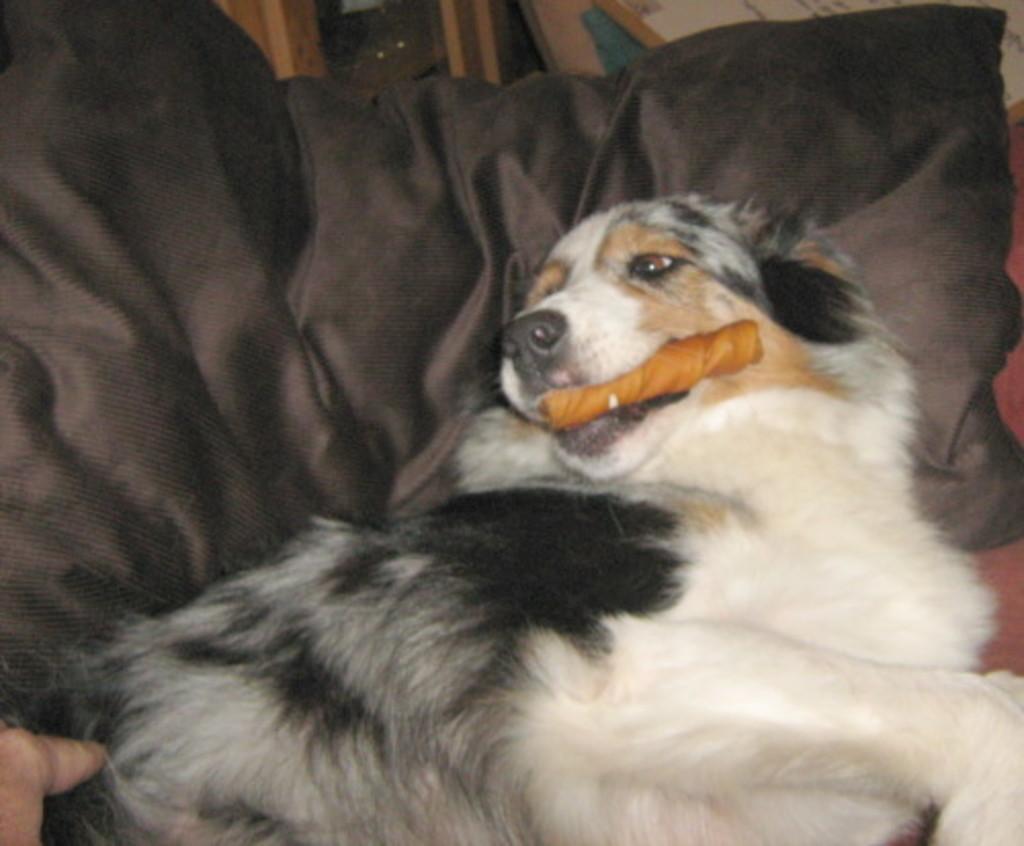In one or two sentences, can you explain what this image depicts? In the image in the center, we can see one roach. On the couch, we can see one pillow and one dog, which is in black and white color. And we can see dog holding some object. In the background there is a wall and a few other objects. 